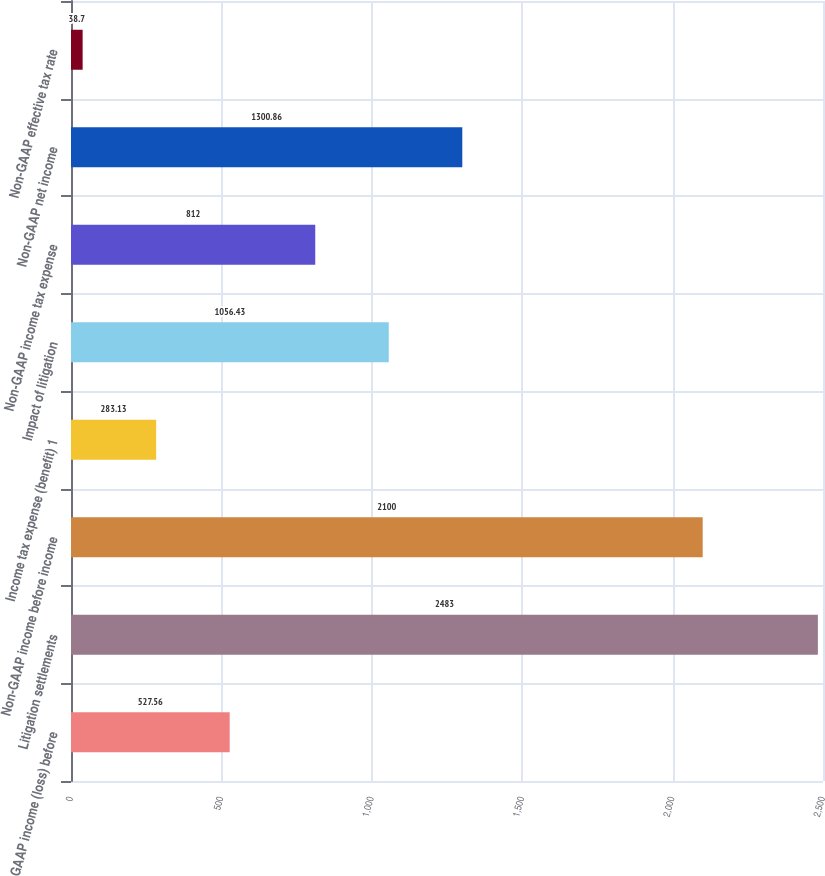Convert chart to OTSL. <chart><loc_0><loc_0><loc_500><loc_500><bar_chart><fcel>GAAP income (loss) before<fcel>Litigation settlements<fcel>Non-GAAP income before income<fcel>Income tax expense (benefit) 1<fcel>Impact of litigation<fcel>Non-GAAP income tax expense<fcel>Non-GAAP net income<fcel>Non-GAAP effective tax rate<nl><fcel>527.56<fcel>2483<fcel>2100<fcel>283.13<fcel>1056.43<fcel>812<fcel>1300.86<fcel>38.7<nl></chart> 